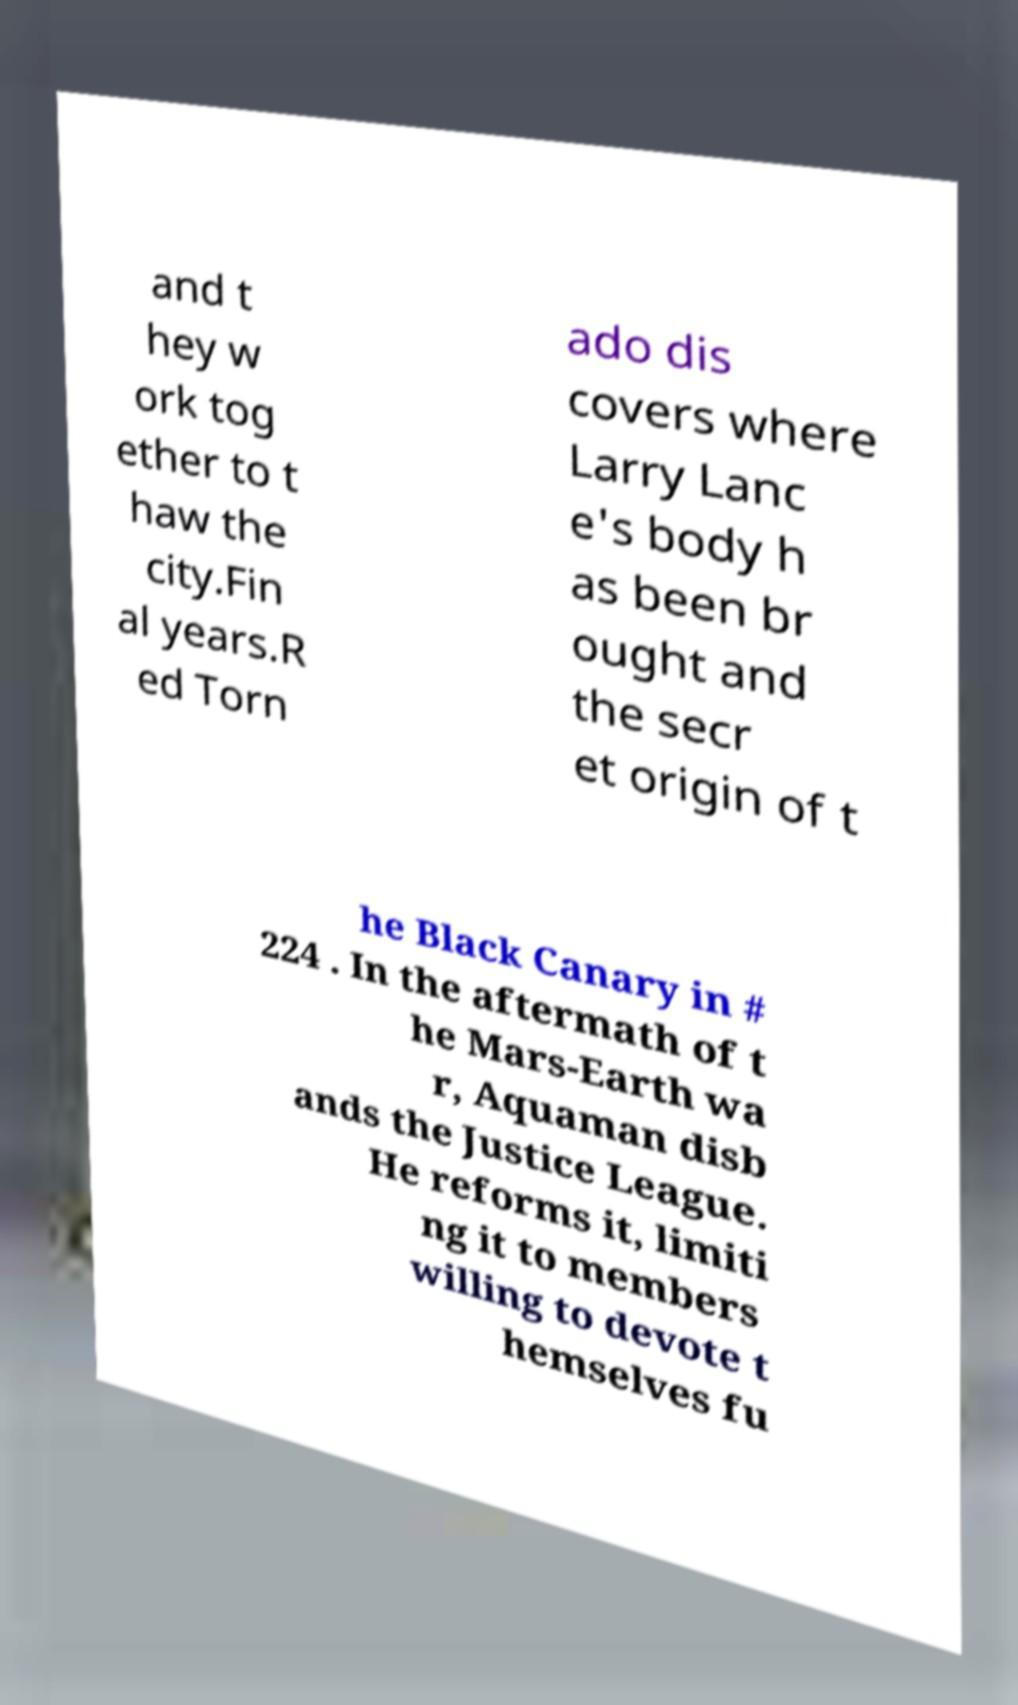I need the written content from this picture converted into text. Can you do that? and t hey w ork tog ether to t haw the city.Fin al years.R ed Torn ado dis covers where Larry Lanc e's body h as been br ought and the secr et origin of t he Black Canary in # 224 . In the aftermath of t he Mars-Earth wa r, Aquaman disb ands the Justice League. He reforms it, limiti ng it to members willing to devote t hemselves fu 